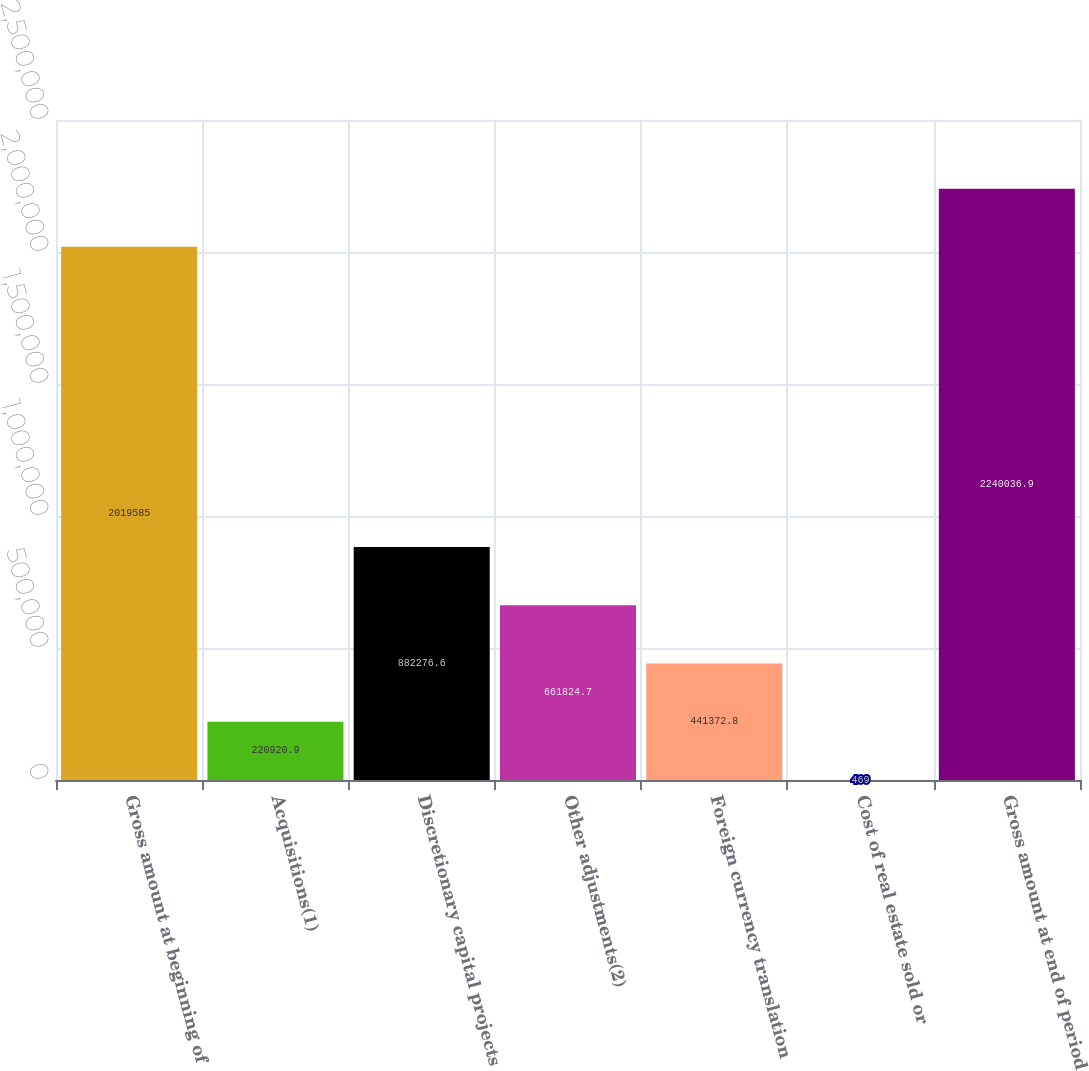Convert chart to OTSL. <chart><loc_0><loc_0><loc_500><loc_500><bar_chart><fcel>Gross amount at beginning of<fcel>Acquisitions(1)<fcel>Discretionary capital projects<fcel>Other adjustments(2)<fcel>Foreign currency translation<fcel>Cost of real estate sold or<fcel>Gross amount at end of period<nl><fcel>2.01958e+06<fcel>220921<fcel>882277<fcel>661825<fcel>441373<fcel>469<fcel>2.24004e+06<nl></chart> 